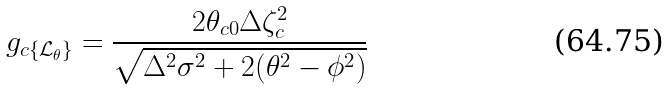<formula> <loc_0><loc_0><loc_500><loc_500>g _ { c \{ \mathcal { L } _ { \theta } \} } = \frac { 2 \theta _ { c 0 } \Delta \zeta _ { c } ^ { 2 } } { \sqrt { \Delta ^ { 2 } \sigma ^ { 2 } + 2 ( \theta ^ { 2 } - \phi ^ { 2 } ) } }</formula> 